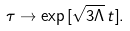Convert formula to latex. <formula><loc_0><loc_0><loc_500><loc_500>\tau \to \exp { [ \sqrt { 3 \Lambda } \, t ] } .</formula> 